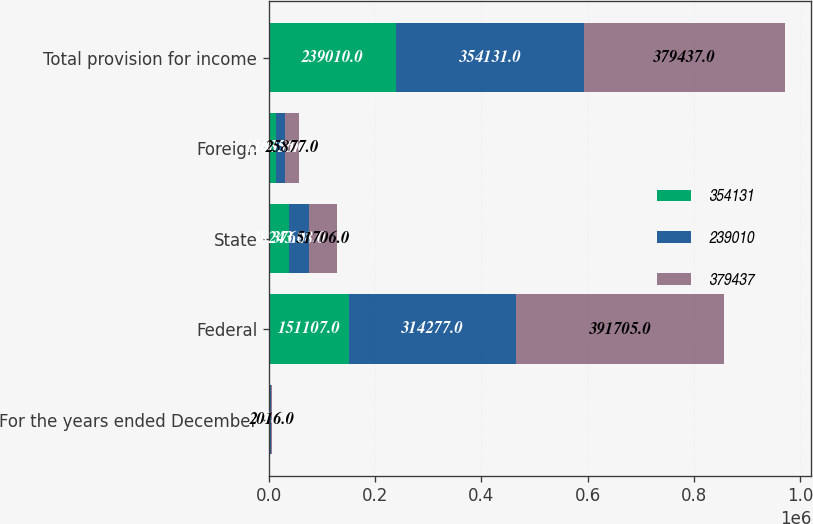<chart> <loc_0><loc_0><loc_500><loc_500><stacked_bar_chart><ecel><fcel>For the years ended December<fcel>Federal<fcel>State<fcel>Foreign<fcel>Total provision for income<nl><fcel>354131<fcel>2018<fcel>151107<fcel>38243<fcel>13405<fcel>239010<nl><fcel>239010<fcel>2017<fcel>314277<fcel>37628<fcel>16356<fcel>354131<nl><fcel>379437<fcel>2016<fcel>391705<fcel>51706<fcel>25877<fcel>379437<nl></chart> 